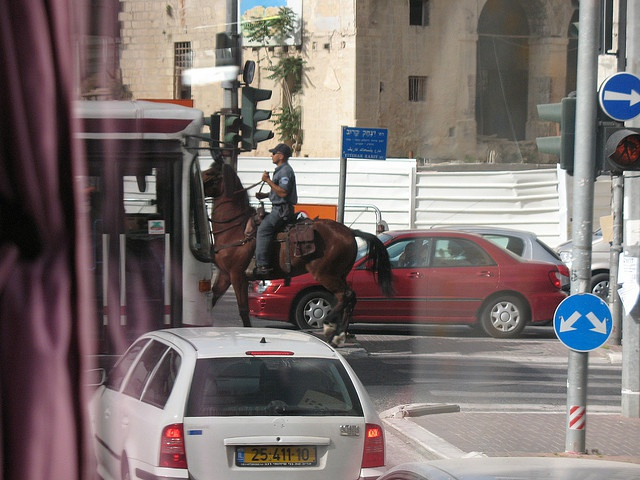Describe the objects in this image and their specific colors. I can see car in black, darkgray, lightgray, and gray tones, bus in black, gray, and darkgray tones, car in black, gray, maroon, and brown tones, horse in black, maroon, and gray tones, and people in black, gray, brown, and purple tones in this image. 